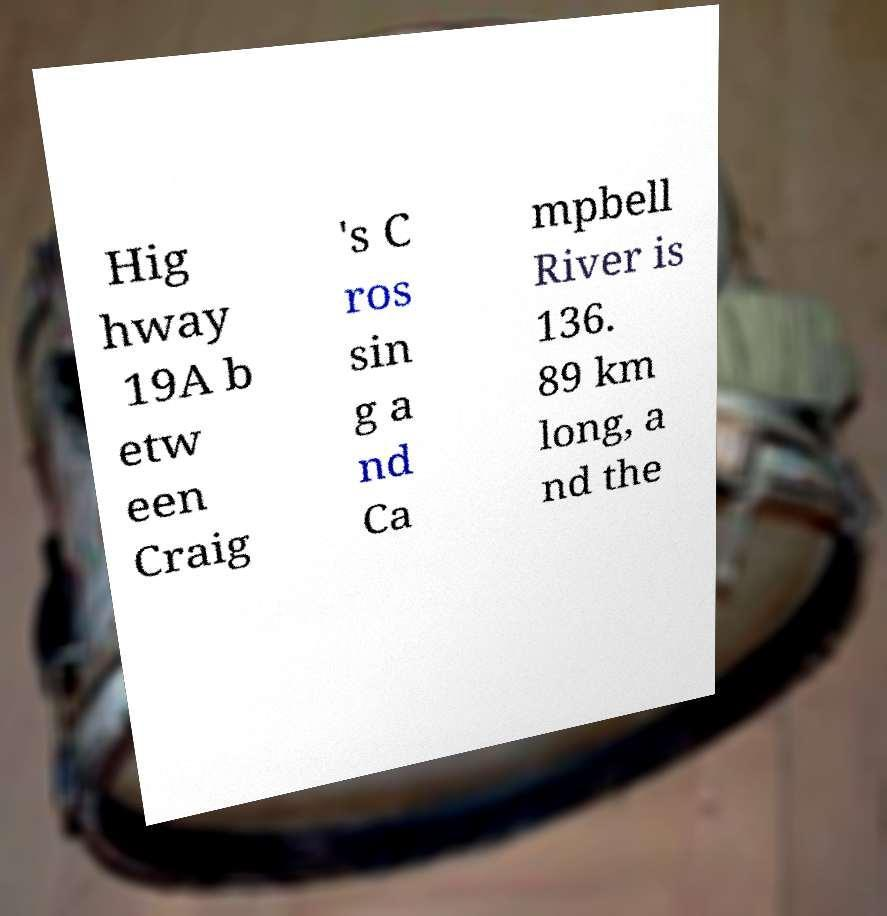Could you assist in decoding the text presented in this image and type it out clearly? Hig hway 19A b etw een Craig 's C ros sin g a nd Ca mpbell River is 136. 89 km long, a nd the 